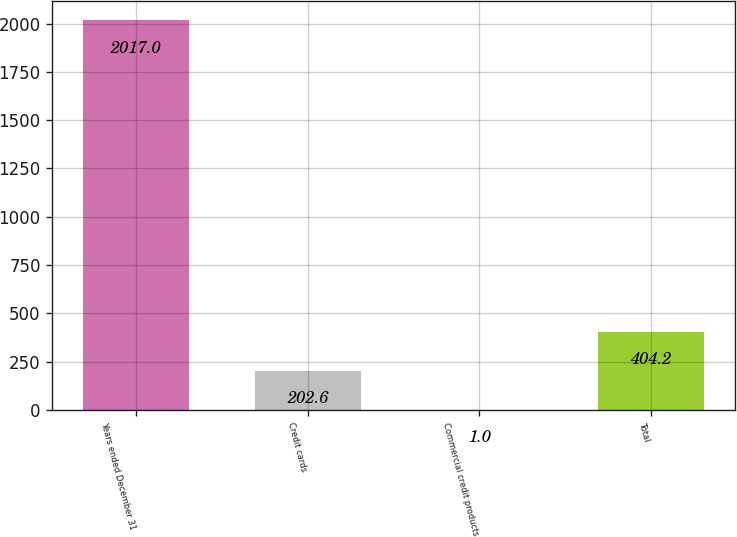<chart> <loc_0><loc_0><loc_500><loc_500><bar_chart><fcel>Years ended December 31<fcel>Credit cards<fcel>Commercial credit products<fcel>Total<nl><fcel>2017<fcel>202.6<fcel>1<fcel>404.2<nl></chart> 